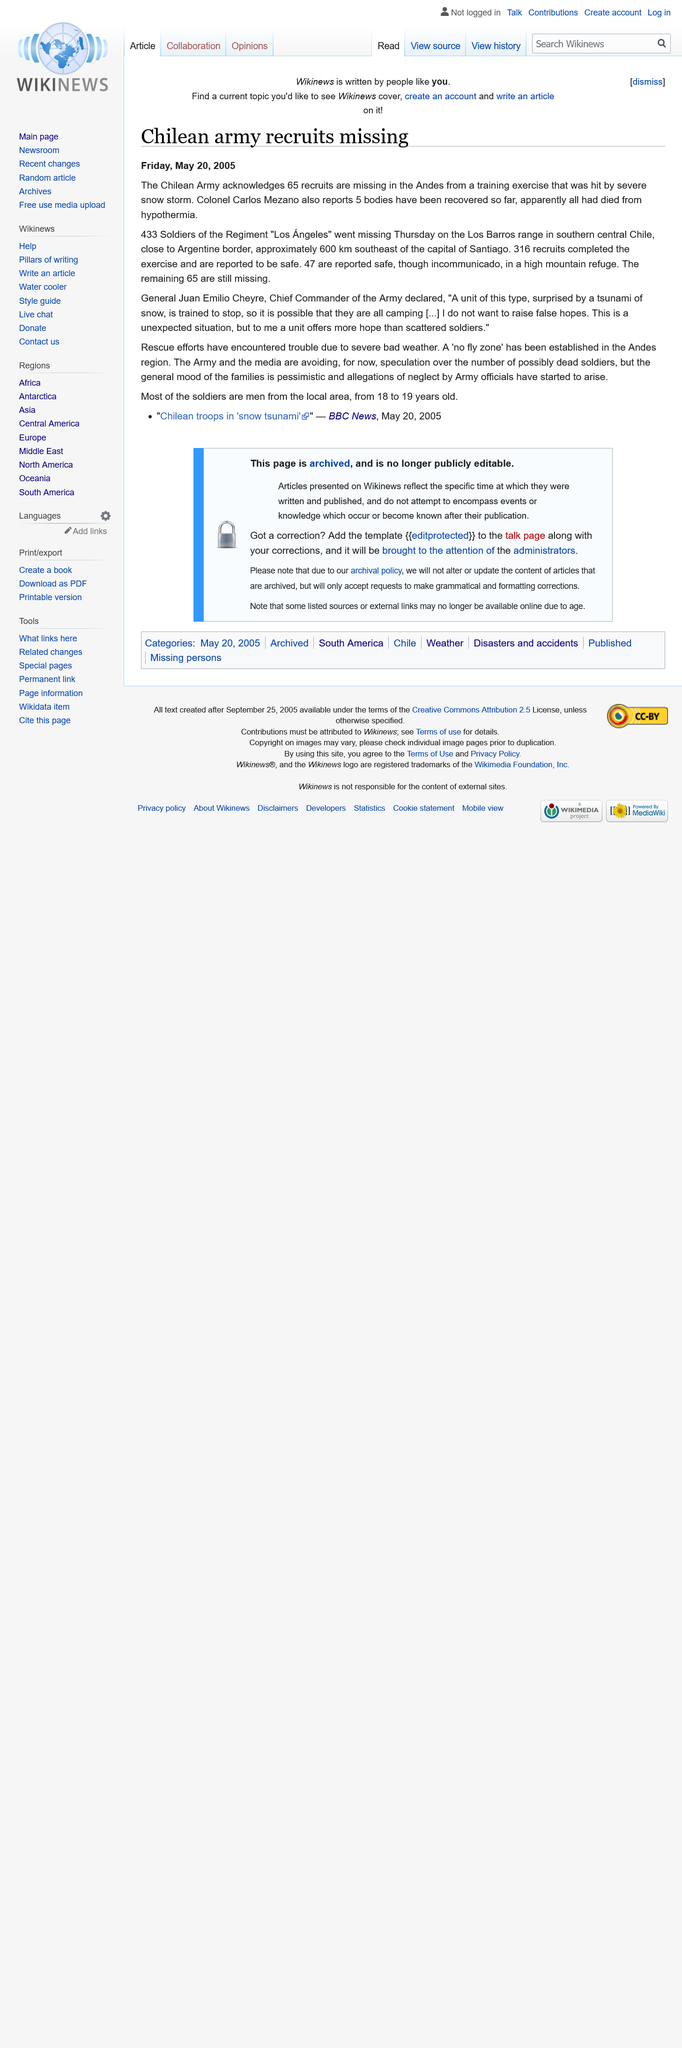List a handful of essential elements in this visual. There are 65 unaccounted for / missing recruits. The recruits are missing, and they are missing in the Andes. Chile was the country from which the missing army recruits were from. 